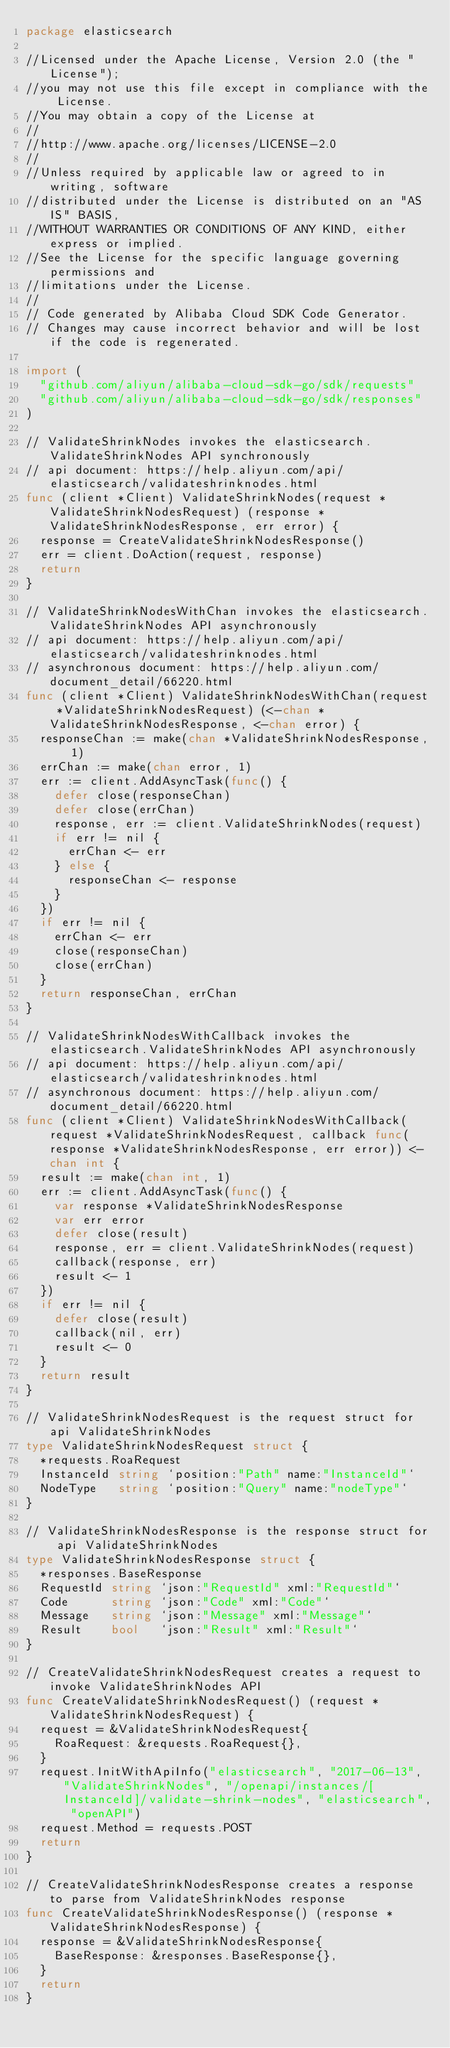Convert code to text. <code><loc_0><loc_0><loc_500><loc_500><_Go_>package elasticsearch

//Licensed under the Apache License, Version 2.0 (the "License");
//you may not use this file except in compliance with the License.
//You may obtain a copy of the License at
//
//http://www.apache.org/licenses/LICENSE-2.0
//
//Unless required by applicable law or agreed to in writing, software
//distributed under the License is distributed on an "AS IS" BASIS,
//WITHOUT WARRANTIES OR CONDITIONS OF ANY KIND, either express or implied.
//See the License for the specific language governing permissions and
//limitations under the License.
//
// Code generated by Alibaba Cloud SDK Code Generator.
// Changes may cause incorrect behavior and will be lost if the code is regenerated.

import (
	"github.com/aliyun/alibaba-cloud-sdk-go/sdk/requests"
	"github.com/aliyun/alibaba-cloud-sdk-go/sdk/responses"
)

// ValidateShrinkNodes invokes the elasticsearch.ValidateShrinkNodes API synchronously
// api document: https://help.aliyun.com/api/elasticsearch/validateshrinknodes.html
func (client *Client) ValidateShrinkNodes(request *ValidateShrinkNodesRequest) (response *ValidateShrinkNodesResponse, err error) {
	response = CreateValidateShrinkNodesResponse()
	err = client.DoAction(request, response)
	return
}

// ValidateShrinkNodesWithChan invokes the elasticsearch.ValidateShrinkNodes API asynchronously
// api document: https://help.aliyun.com/api/elasticsearch/validateshrinknodes.html
// asynchronous document: https://help.aliyun.com/document_detail/66220.html
func (client *Client) ValidateShrinkNodesWithChan(request *ValidateShrinkNodesRequest) (<-chan *ValidateShrinkNodesResponse, <-chan error) {
	responseChan := make(chan *ValidateShrinkNodesResponse, 1)
	errChan := make(chan error, 1)
	err := client.AddAsyncTask(func() {
		defer close(responseChan)
		defer close(errChan)
		response, err := client.ValidateShrinkNodes(request)
		if err != nil {
			errChan <- err
		} else {
			responseChan <- response
		}
	})
	if err != nil {
		errChan <- err
		close(responseChan)
		close(errChan)
	}
	return responseChan, errChan
}

// ValidateShrinkNodesWithCallback invokes the elasticsearch.ValidateShrinkNodes API asynchronously
// api document: https://help.aliyun.com/api/elasticsearch/validateshrinknodes.html
// asynchronous document: https://help.aliyun.com/document_detail/66220.html
func (client *Client) ValidateShrinkNodesWithCallback(request *ValidateShrinkNodesRequest, callback func(response *ValidateShrinkNodesResponse, err error)) <-chan int {
	result := make(chan int, 1)
	err := client.AddAsyncTask(func() {
		var response *ValidateShrinkNodesResponse
		var err error
		defer close(result)
		response, err = client.ValidateShrinkNodes(request)
		callback(response, err)
		result <- 1
	})
	if err != nil {
		defer close(result)
		callback(nil, err)
		result <- 0
	}
	return result
}

// ValidateShrinkNodesRequest is the request struct for api ValidateShrinkNodes
type ValidateShrinkNodesRequest struct {
	*requests.RoaRequest
	InstanceId string `position:"Path" name:"InstanceId"`
	NodeType   string `position:"Query" name:"nodeType"`
}

// ValidateShrinkNodesResponse is the response struct for api ValidateShrinkNodes
type ValidateShrinkNodesResponse struct {
	*responses.BaseResponse
	RequestId string `json:"RequestId" xml:"RequestId"`
	Code      string `json:"Code" xml:"Code"`
	Message   string `json:"Message" xml:"Message"`
	Result    bool   `json:"Result" xml:"Result"`
}

// CreateValidateShrinkNodesRequest creates a request to invoke ValidateShrinkNodes API
func CreateValidateShrinkNodesRequest() (request *ValidateShrinkNodesRequest) {
	request = &ValidateShrinkNodesRequest{
		RoaRequest: &requests.RoaRequest{},
	}
	request.InitWithApiInfo("elasticsearch", "2017-06-13", "ValidateShrinkNodes", "/openapi/instances/[InstanceId]/validate-shrink-nodes", "elasticsearch", "openAPI")
	request.Method = requests.POST
	return
}

// CreateValidateShrinkNodesResponse creates a response to parse from ValidateShrinkNodes response
func CreateValidateShrinkNodesResponse() (response *ValidateShrinkNodesResponse) {
	response = &ValidateShrinkNodesResponse{
		BaseResponse: &responses.BaseResponse{},
	}
	return
}
</code> 